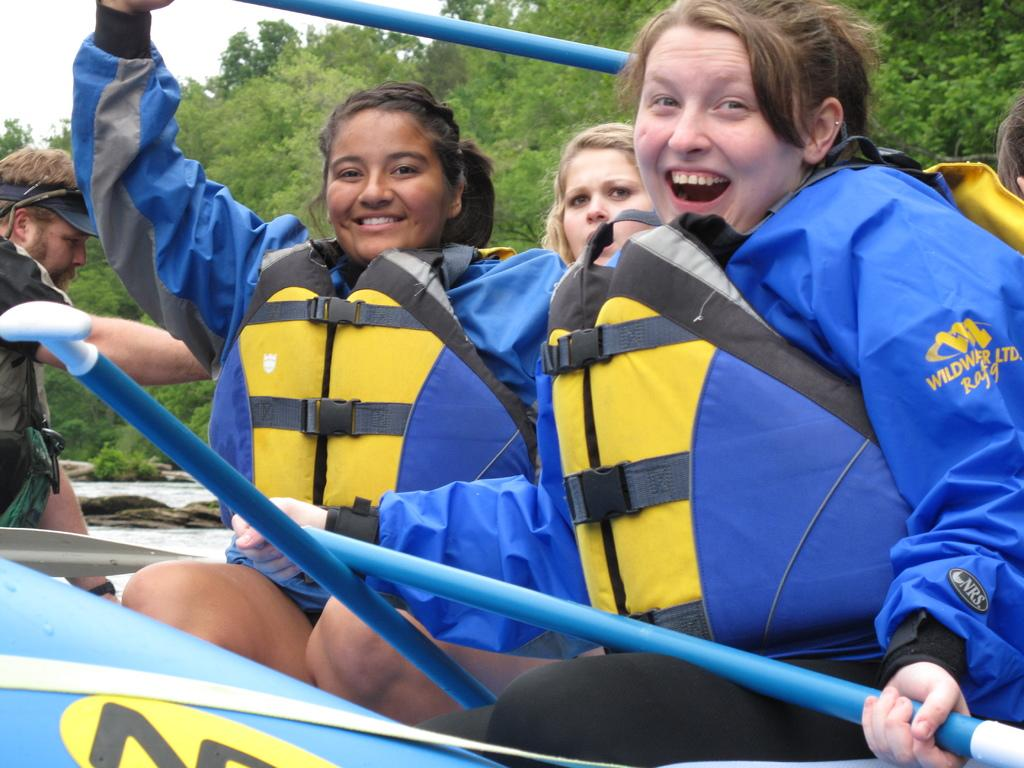What are the people in the image doing? There is a group of people sitting in the image. What can be seen in the background of the image? There are trees and the sky visible in the background of the image. What type of texture can be seen on the writing in the image? There is no writing present in the image, so there is no texture to describe. 